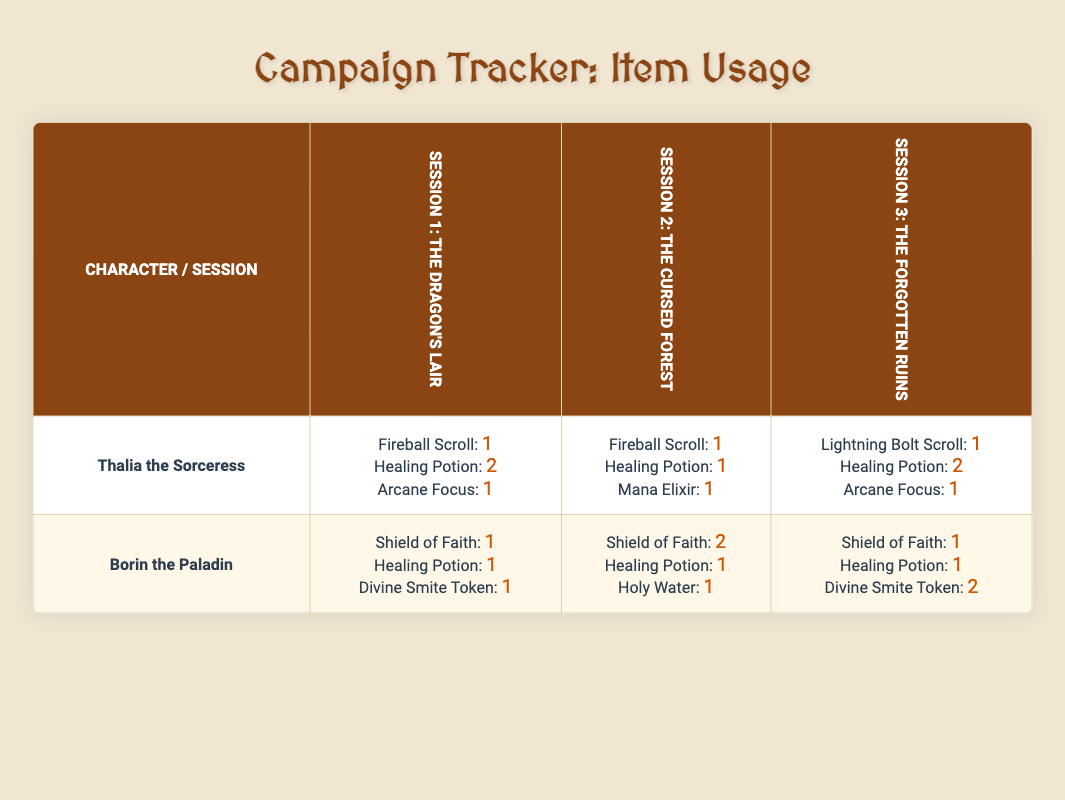What item did Thalia the Sorceress use the most in Session 1? In Session 1, the table shows that Thalia the Sorceress used a total of 1 Fireball Scroll, 2 Healing Potions, and 1 Arcane Focus. The Healing Potion has the highest count at 2, making it the item used the most.
Answer: Healing Potion How many Healing Potions did Borin the Paladin use across all sessions? From the table, Borin the Paladin used 1 Healing Potion in Session 1, 1 Healing Potion in Session 2, and 1 Healing Potion in Session 3. Adding these values together gives 1 + 1 + 1 = 3.
Answer: 3 Did Thalia the Sorceress use any Mana Elixirs in the sessions? The table shows that Thalia the Sorceress used 1 Mana Elixir in Session 2 but none in Sessions 1 and 3. Based on this, the answer is true.
Answer: Yes What is the total number of items used by Borin the Paladin in Session 2? In Session 2, Borin the Paladin used 2 Shield of Faith, 1 Healing Potion, and 1 Holy Water. To find the total, we sum these: 2 + 1 + 1 = 4.
Answer: 4 Which character used the Lightning Bolt Scroll, and in which session? According to the table, only Thalia the Sorceress used the Lightning Bolt Scroll, which she used in Session 3.
Answer: Thalia the Sorceress in Session 3 How many more Healing Potions did Thalia the Sorceress use compared to Borin the Paladin in Session 1? In Session 1, Thalia used 2 Healing Potions and Borin used 1 Healing Potion. The difference is 2 - 1 = 1. Thus, Thalia used 1 more Healing Potion.
Answer: 1 more What is the average usage of Shield of Faith for Borin the Paladin across all sessions? Borin the Paladin used 1 Shield of Faith in Session 1, 2 in Session 2, and 1 in Session 3. Adding these gives a total of 1 + 2 + 1 = 4. There are 3 sessions, so the average is 4 / 3 = 1.33.
Answer: 1.33 Did the use of Divine Smite Token increase in the later sessions for Borin the Paladin? The usage of Divine Smite Token shows 1 in Session 1, 0 in Session 2, and 2 in Session 3. The values indicate a decrease from Session 1 to Session 2 (from 1 to 0), but then an increase from Session 2 to Session 3 (from 0 to 2). Therefore, overall there was an increase when comparing the first and last sessions.
Answer: Yes 